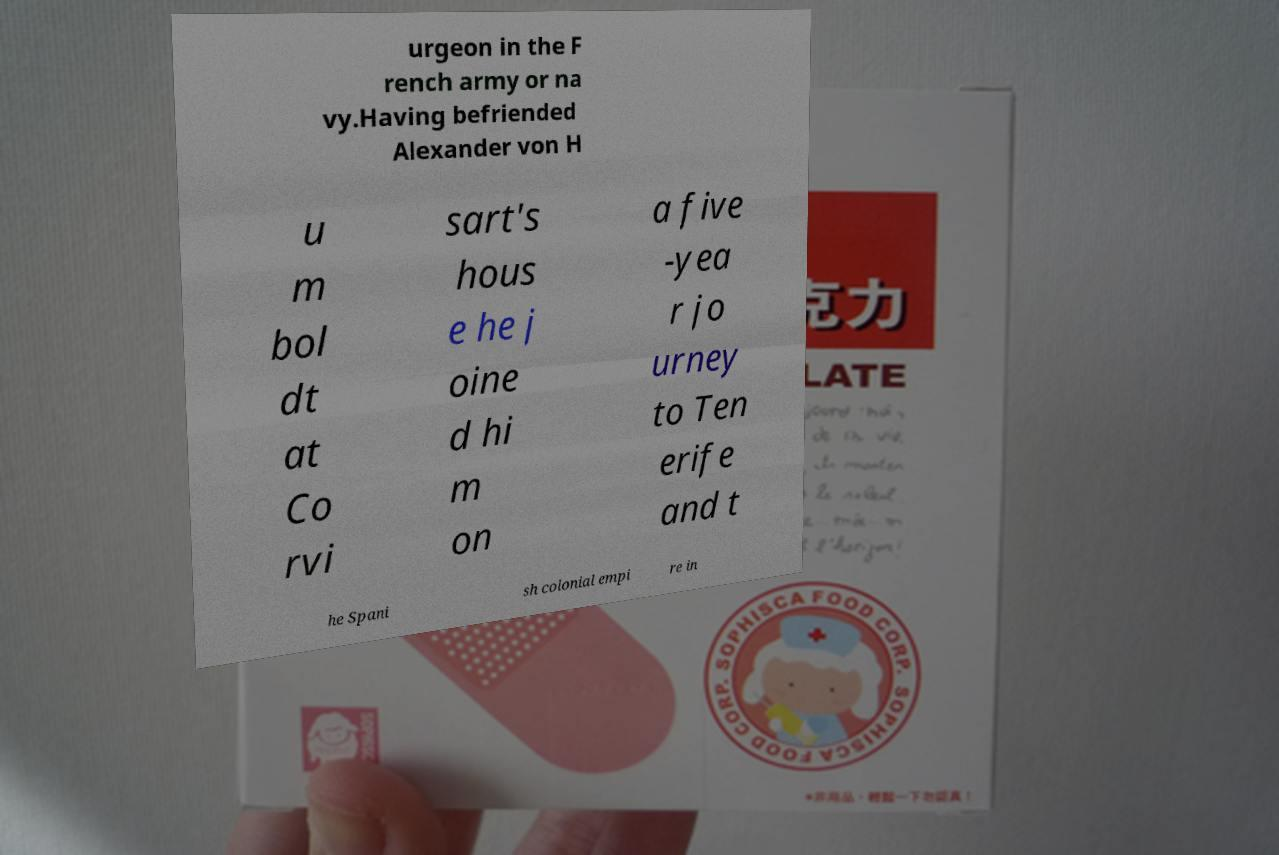There's text embedded in this image that I need extracted. Can you transcribe it verbatim? urgeon in the F rench army or na vy.Having befriended Alexander von H u m bol dt at Co rvi sart's hous e he j oine d hi m on a five -yea r jo urney to Ten erife and t he Spani sh colonial empi re in 